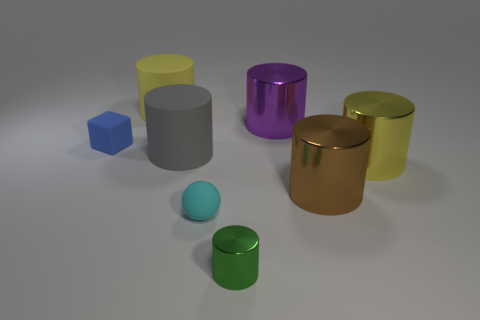There is a yellow cylinder that is in front of the big yellow thing that is on the left side of the big purple shiny cylinder; are there any big yellow matte cylinders that are to the left of it?
Your answer should be very brief. Yes. What number of cylinders are blue matte objects or brown objects?
Your answer should be compact. 1. What material is the yellow object that is in front of the tiny rubber block?
Your answer should be very brief. Metal. Does the big metallic thing that is on the right side of the brown metallic thing have the same color as the small object that is on the left side of the small rubber sphere?
Ensure brevity in your answer.  No. How many objects are yellow cylinders or small matte things?
Your response must be concise. 4. How many other objects are the same shape as the gray matte thing?
Your response must be concise. 5. Is the material of the large yellow cylinder right of the large gray cylinder the same as the cylinder in front of the tiny ball?
Give a very brief answer. Yes. The thing that is both to the right of the cyan thing and in front of the big brown metal cylinder has what shape?
Offer a very short reply. Cylinder. Is there any other thing that has the same material as the small cyan object?
Your answer should be very brief. Yes. What is the thing that is both in front of the big yellow metallic cylinder and behind the cyan rubber ball made of?
Your response must be concise. Metal. 